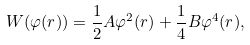Convert formula to latex. <formula><loc_0><loc_0><loc_500><loc_500>W ( \varphi ( r ) ) = \frac { 1 } { 2 } A \varphi ^ { 2 } ( r ) + \frac { 1 } { 4 } B \varphi ^ { 4 } ( r ) ,</formula> 